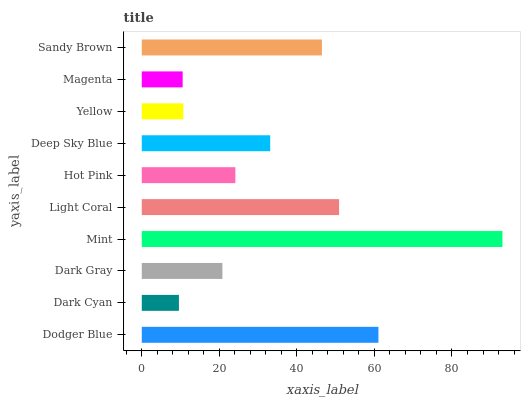Is Dark Cyan the minimum?
Answer yes or no. Yes. Is Mint the maximum?
Answer yes or no. Yes. Is Dark Gray the minimum?
Answer yes or no. No. Is Dark Gray the maximum?
Answer yes or no. No. Is Dark Gray greater than Dark Cyan?
Answer yes or no. Yes. Is Dark Cyan less than Dark Gray?
Answer yes or no. Yes. Is Dark Cyan greater than Dark Gray?
Answer yes or no. No. Is Dark Gray less than Dark Cyan?
Answer yes or no. No. Is Deep Sky Blue the high median?
Answer yes or no. Yes. Is Hot Pink the low median?
Answer yes or no. Yes. Is Light Coral the high median?
Answer yes or no. No. Is Yellow the low median?
Answer yes or no. No. 